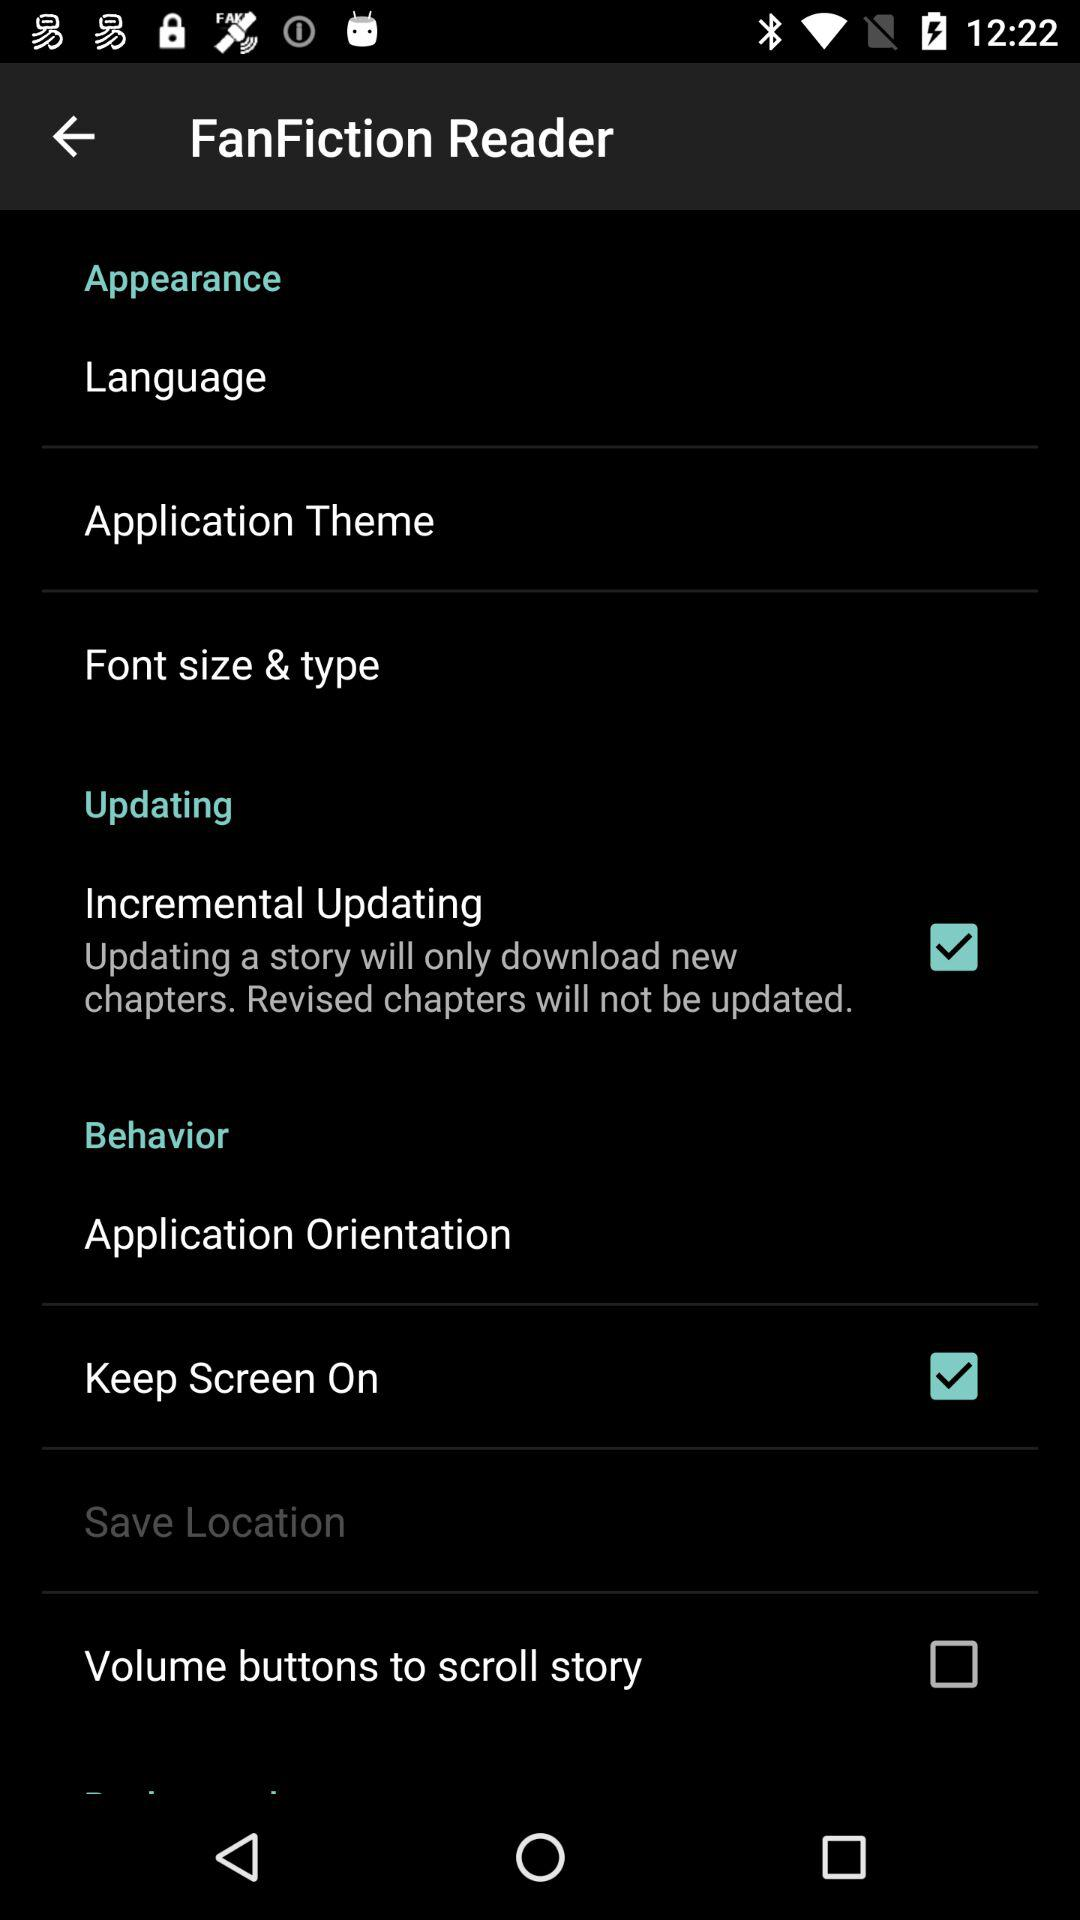What is the status of "Volume buttons to scroll story"? The status is off. 